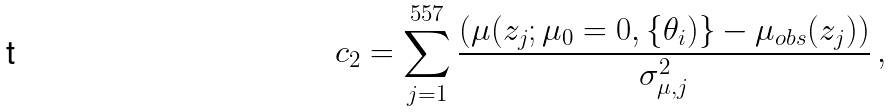Convert formula to latex. <formula><loc_0><loc_0><loc_500><loc_500>c _ { 2 } = \sum ^ { 5 5 7 } _ { j = 1 } \frac { ( \mu ( z _ { j } ; \mu _ { 0 } = 0 , \{ \theta _ { i } ) \} - \mu _ { o b s } ( z _ { j } ) ) } { \sigma ^ { 2 } _ { \mu , j } } \, ,</formula> 